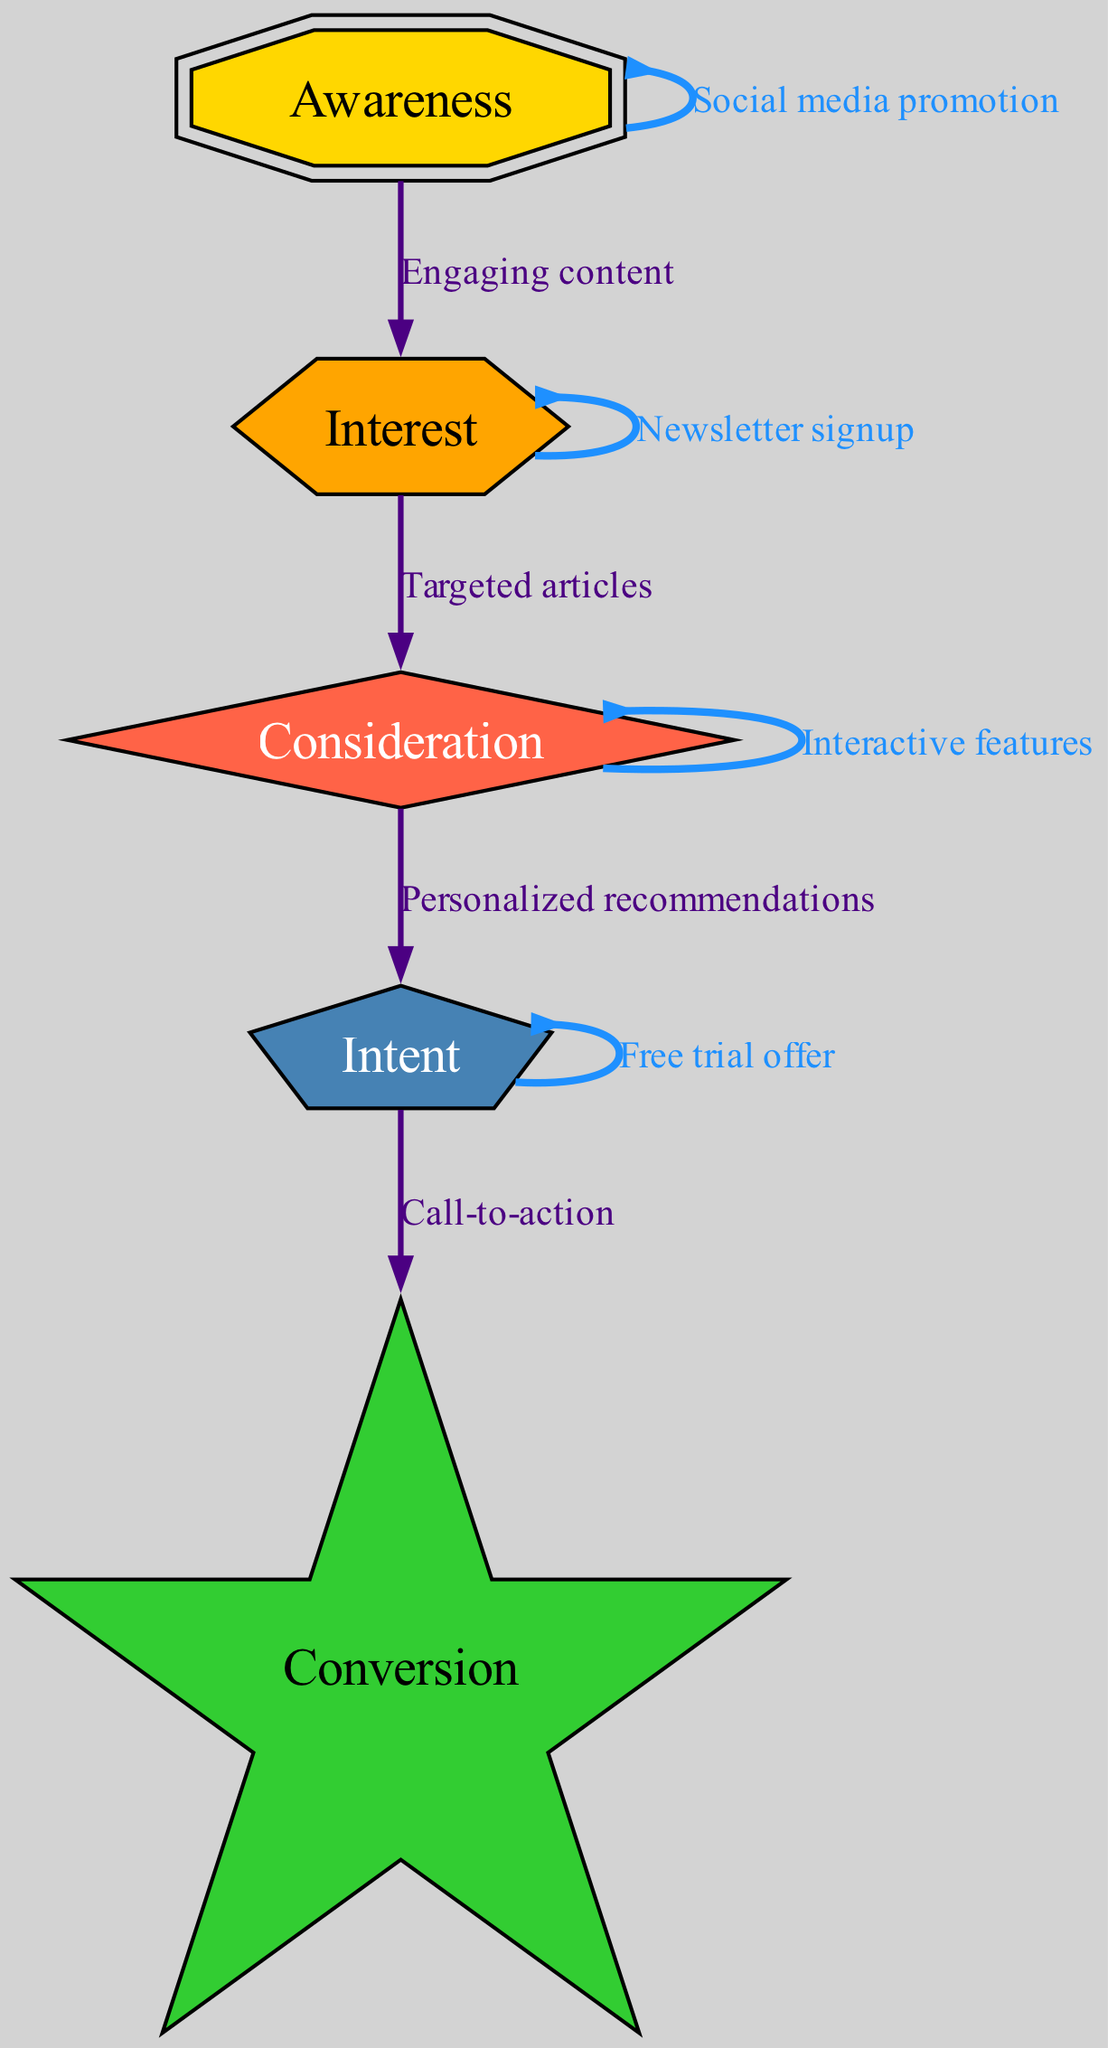What are the five stages in the audience engagement funnel? The diagram shows five stages: Awareness, Interest, Consideration, Intent, and Conversion. These nodes are clearly labeled and represent the flow in the engagement process.
Answer: Awareness, Interest, Consideration, Intent, Conversion What type of edge connects "Awareness" to "Interest"? The edge from "Awareness" to "Interest" is labeled "Engaging content," indicating the action that transitions users from being aware to developing interest. This label is shown along the connecting line in the diagram.
Answer: Engaging content How many edges are there in the diagram? By counting the connections shown between the nodes, including self-loops, the diagram contains a total of eight edges. Each edge connects two nodes and some are loops back to themselves.
Answer: Eight Which stage does "Personalized recommendations" connect to? The label "Personalized recommendations" on the connecting edge indicates that this action transitions a user from "Consideration" to "Intent." Tracing the path in the diagram makes this relationship clear.
Answer: Intent What self-loop edge is present at the "Interest" stage? The self-loop edge at the "Interest" stage is labeled "Newsletter signup." This means that within the interest stage, users can re-engage with the process by signing up for newsletters.
Answer: Newsletter signup What is the final action that leads to "Conversion"? The final action that leads to "Conversion" is represented by the edge labeled "Call-to-action." This edge connects the stage of Intent to Conversion, clearly indicating the last push before final conversion occurs.
Answer: Call-to-action Which two stages are connected by "Targeted articles"? The "Targeted articles" edge connects "Interest" to "Consideration." This indicates that after developing interest, users can be further engaged with articles tailored to their needs and preferences.
Answer: Consideration What shape represents the "Conversion" node? The "Conversion" node is represented by a star shape, which visually distinguishes it from other stages and signifies its importance as the final goal of the engagement funnel.
Answer: Star 